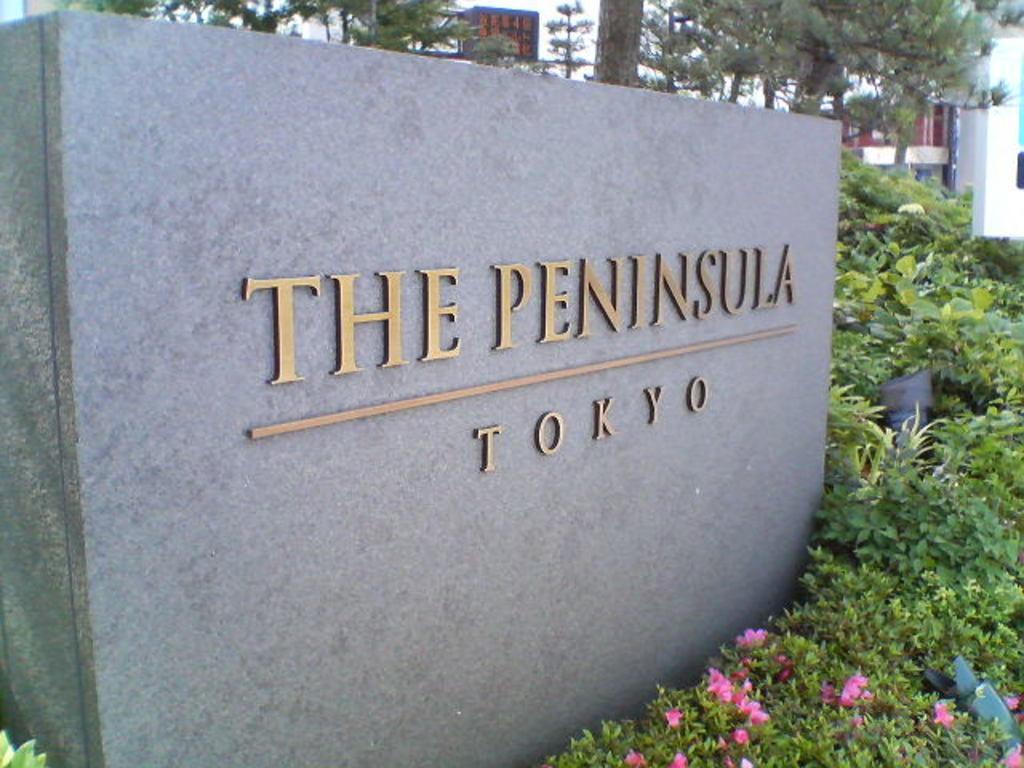How would you summarize this image in a sentence or two? In the center of the image there is a wall with some text. In front of the wall, we can see plants with flowers and some objects. In the background, we can see buildings and trees. 